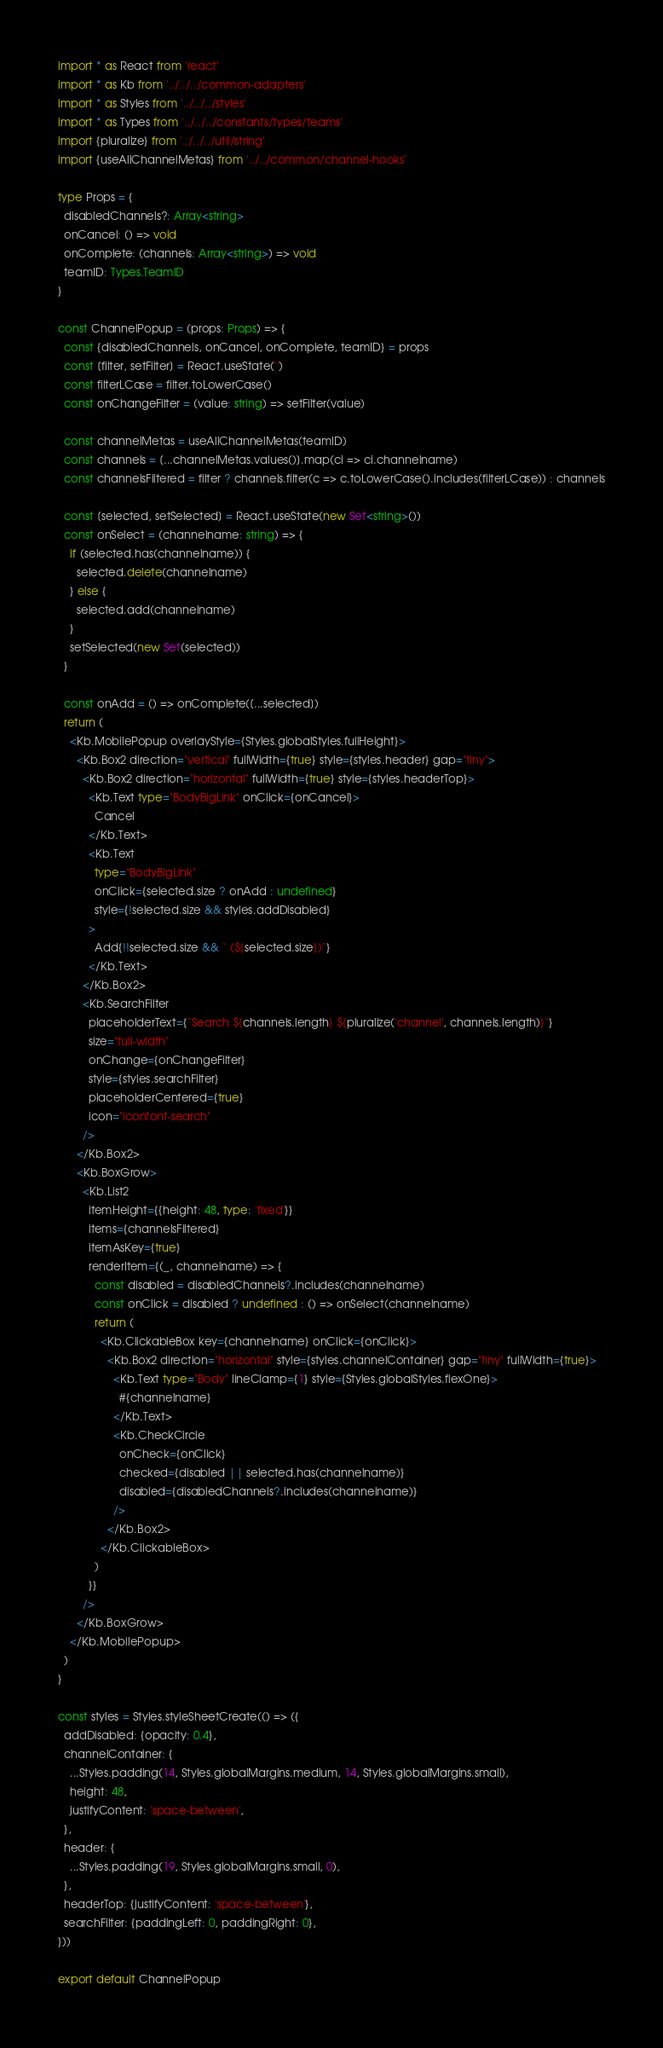<code> <loc_0><loc_0><loc_500><loc_500><_TypeScript_>import * as React from 'react'
import * as Kb from '../../../common-adapters'
import * as Styles from '../../../styles'
import * as Types from '../../../constants/types/teams'
import {pluralize} from '../../../util/string'
import {useAllChannelMetas} from '../../common/channel-hooks'

type Props = {
  disabledChannels?: Array<string>
  onCancel: () => void
  onComplete: (channels: Array<string>) => void
  teamID: Types.TeamID
}

const ChannelPopup = (props: Props) => {
  const {disabledChannels, onCancel, onComplete, teamID} = props
  const [filter, setFilter] = React.useState('')
  const filterLCase = filter.toLowerCase()
  const onChangeFilter = (value: string) => setFilter(value)

  const channelMetas = useAllChannelMetas(teamID)
  const channels = [...channelMetas.values()].map(ci => ci.channelname)
  const channelsFiltered = filter ? channels.filter(c => c.toLowerCase().includes(filterLCase)) : channels

  const [selected, setSelected] = React.useState(new Set<string>())
  const onSelect = (channelname: string) => {
    if (selected.has(channelname)) {
      selected.delete(channelname)
    } else {
      selected.add(channelname)
    }
    setSelected(new Set(selected))
  }

  const onAdd = () => onComplete([...selected])
  return (
    <Kb.MobilePopup overlayStyle={Styles.globalStyles.fullHeight}>
      <Kb.Box2 direction="vertical" fullWidth={true} style={styles.header} gap="tiny">
        <Kb.Box2 direction="horizontal" fullWidth={true} style={styles.headerTop}>
          <Kb.Text type="BodyBigLink" onClick={onCancel}>
            Cancel
          </Kb.Text>
          <Kb.Text
            type="BodyBigLink"
            onClick={selected.size ? onAdd : undefined}
            style={!selected.size && styles.addDisabled}
          >
            Add{!!selected.size && ` (${selected.size})`}
          </Kb.Text>
        </Kb.Box2>
        <Kb.SearchFilter
          placeholderText={`Search ${channels.length} ${pluralize('channel', channels.length)}`}
          size="full-width"
          onChange={onChangeFilter}
          style={styles.searchFilter}
          placeholderCentered={true}
          icon="iconfont-search"
        />
      </Kb.Box2>
      <Kb.BoxGrow>
        <Kb.List2
          itemHeight={{height: 48, type: 'fixed'}}
          items={channelsFiltered}
          itemAsKey={true}
          renderItem={(_, channelname) => {
            const disabled = disabledChannels?.includes(channelname)
            const onClick = disabled ? undefined : () => onSelect(channelname)
            return (
              <Kb.ClickableBox key={channelname} onClick={onClick}>
                <Kb.Box2 direction="horizontal" style={styles.channelContainer} gap="tiny" fullWidth={true}>
                  <Kb.Text type="Body" lineClamp={1} style={Styles.globalStyles.flexOne}>
                    #{channelname}
                  </Kb.Text>
                  <Kb.CheckCircle
                    onCheck={onClick}
                    checked={disabled || selected.has(channelname)}
                    disabled={disabledChannels?.includes(channelname)}
                  />
                </Kb.Box2>
              </Kb.ClickableBox>
            )
          }}
        />
      </Kb.BoxGrow>
    </Kb.MobilePopup>
  )
}

const styles = Styles.styleSheetCreate(() => ({
  addDisabled: {opacity: 0.4},
  channelContainer: {
    ...Styles.padding(14, Styles.globalMargins.medium, 14, Styles.globalMargins.small),
    height: 48,
    justifyContent: 'space-between',
  },
  header: {
    ...Styles.padding(19, Styles.globalMargins.small, 0),
  },
  headerTop: {justifyContent: 'space-between'},
  searchFilter: {paddingLeft: 0, paddingRight: 0},
}))

export default ChannelPopup
</code> 